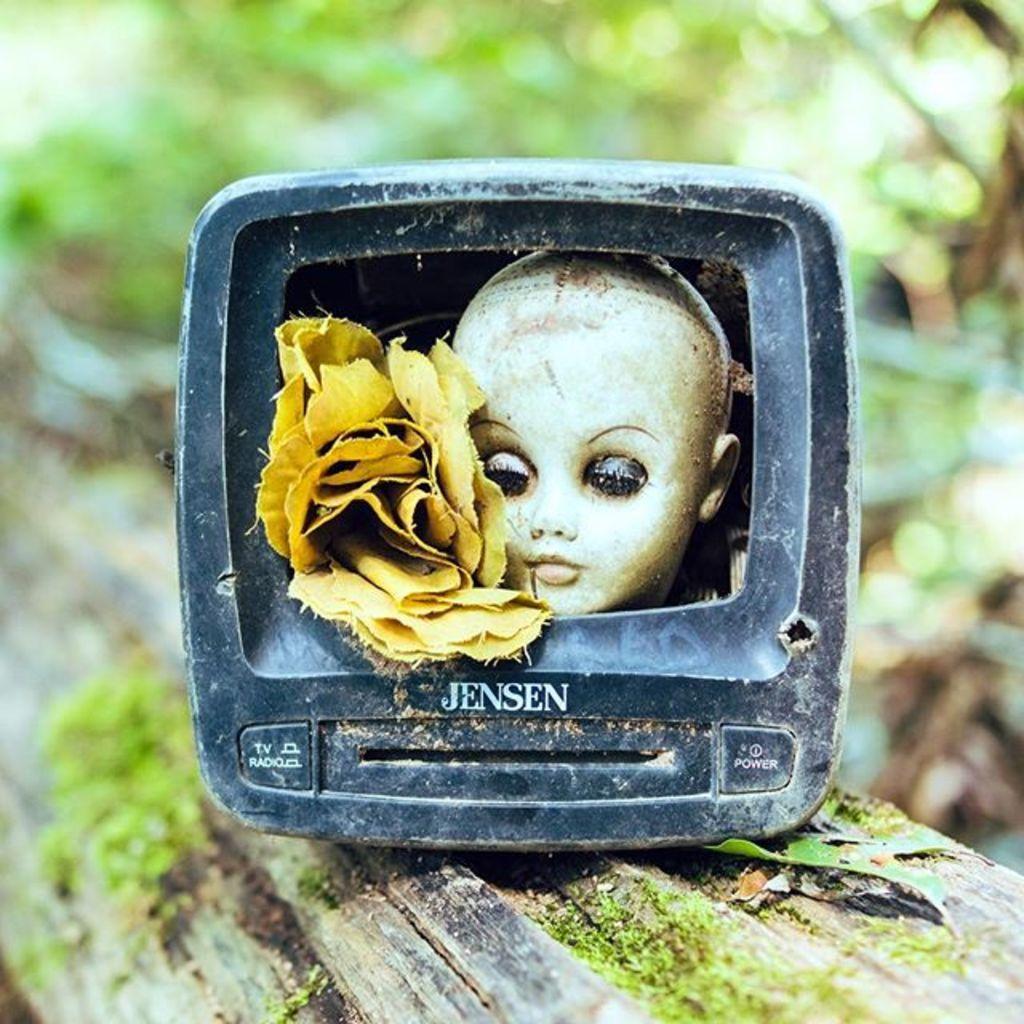Can you describe this image briefly? In this image there is a an object on a wood log. In the object there are flowers and a face of a doll. There is text on the object. There is algae on the log. The background is blurry. 